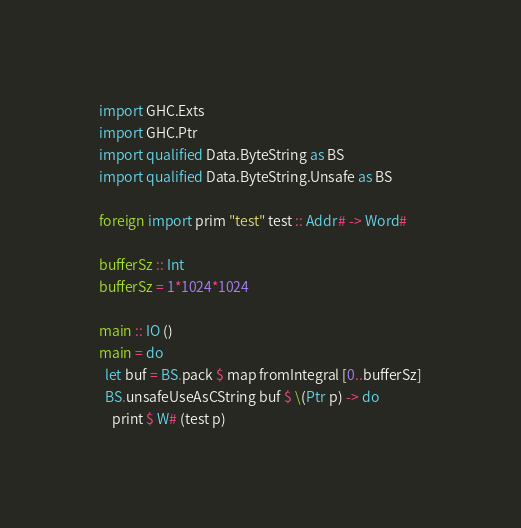<code> <loc_0><loc_0><loc_500><loc_500><_Haskell_>import GHC.Exts
import GHC.Ptr
import qualified Data.ByteString as BS
import qualified Data.ByteString.Unsafe as BS

foreign import prim "test" test :: Addr# -> Word#

bufferSz :: Int
bufferSz = 1*1024*1024

main :: IO ()
main = do
  let buf = BS.pack $ map fromIntegral [0..bufferSz]
  BS.unsafeUseAsCString buf $ \(Ptr p) -> do
    print $ W# (test p)

</code> 